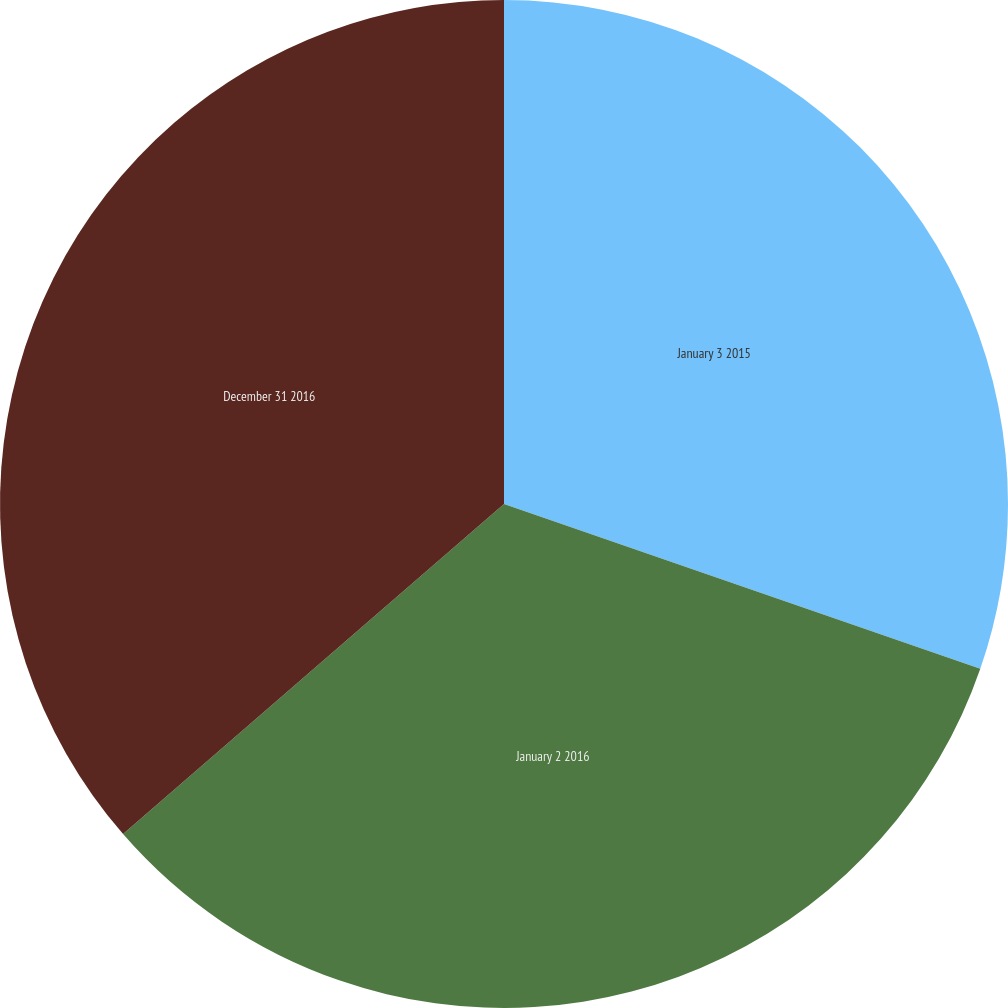Convert chart to OTSL. <chart><loc_0><loc_0><loc_500><loc_500><pie_chart><fcel>January 3 2015<fcel>January 2 2016<fcel>December 31 2016<nl><fcel>30.3%<fcel>33.33%<fcel>36.36%<nl></chart> 